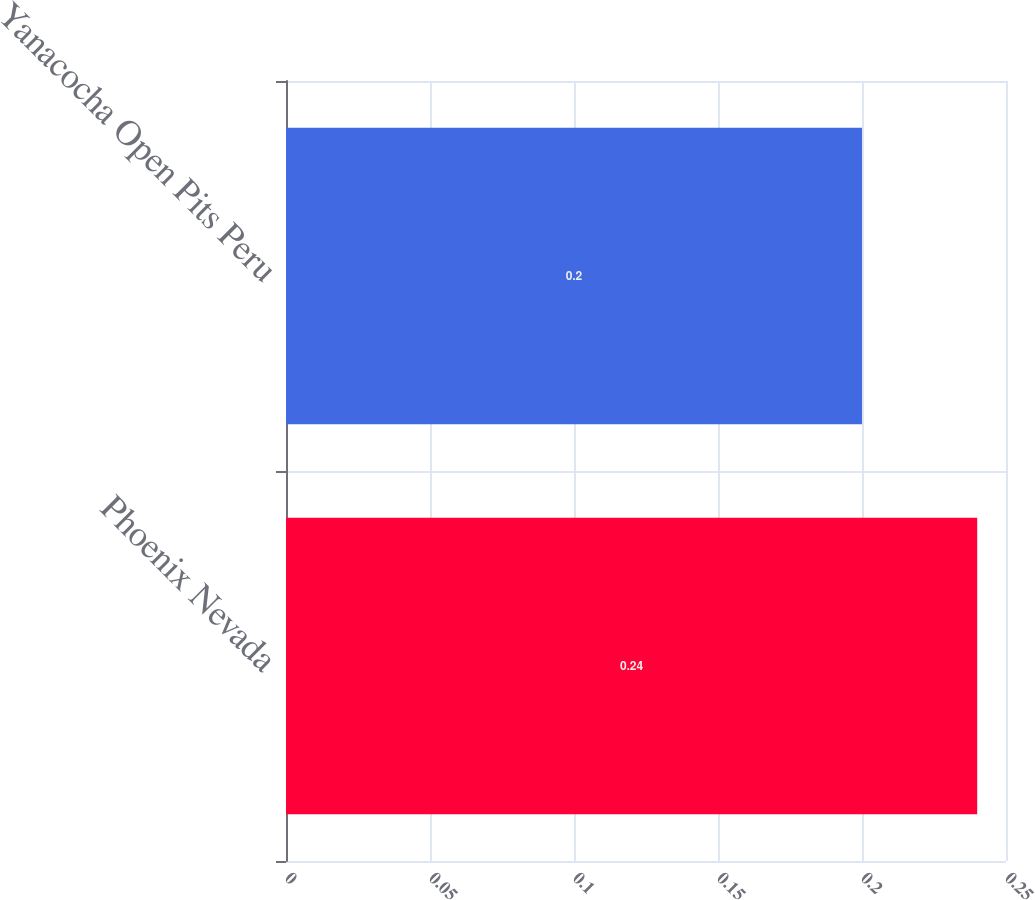Convert chart to OTSL. <chart><loc_0><loc_0><loc_500><loc_500><bar_chart><fcel>Phoenix Nevada<fcel>Yanacocha Open Pits Peru<nl><fcel>0.24<fcel>0.2<nl></chart> 